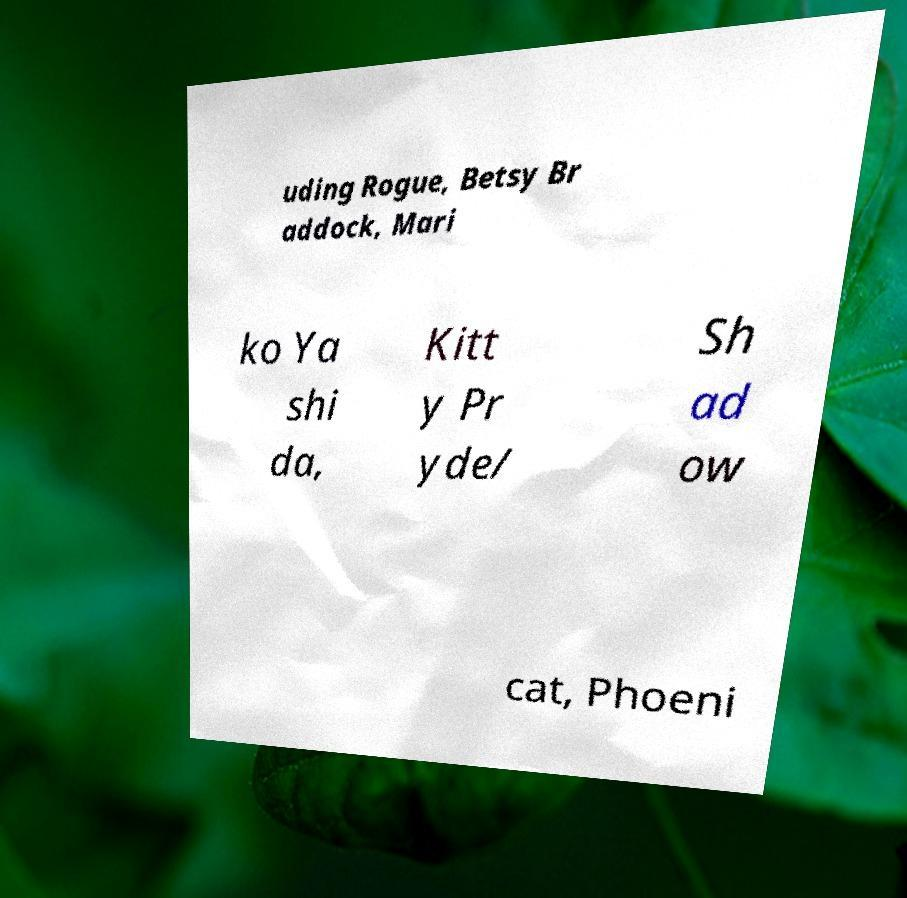Could you extract and type out the text from this image? uding Rogue, Betsy Br addock, Mari ko Ya shi da, Kitt y Pr yde/ Sh ad ow cat, Phoeni 